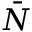<formula> <loc_0><loc_0><loc_500><loc_500>\bar { N }</formula> 